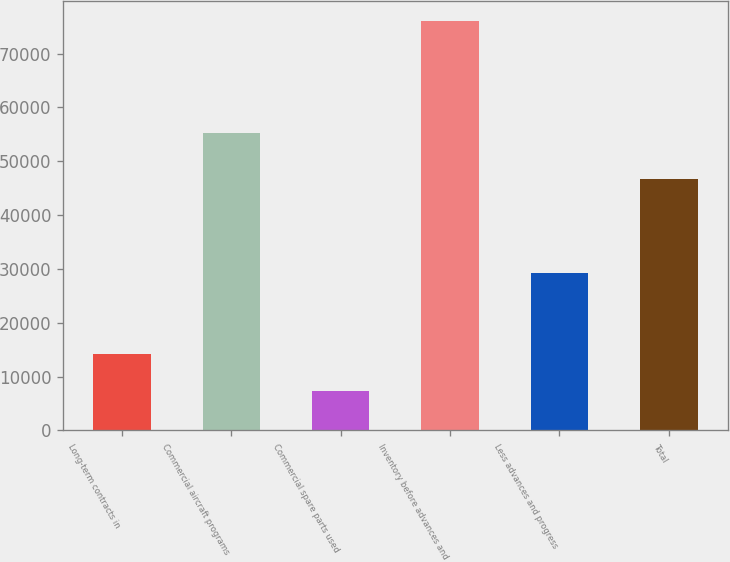<chart> <loc_0><loc_0><loc_500><loc_500><bar_chart><fcel>Long-term contracts in<fcel>Commercial aircraft programs<fcel>Commercial spare parts used<fcel>Inventory before advances and<fcel>Less advances and progress<fcel>Total<nl><fcel>14281.1<fcel>55220<fcel>7421<fcel>76022<fcel>29266<fcel>46756<nl></chart> 